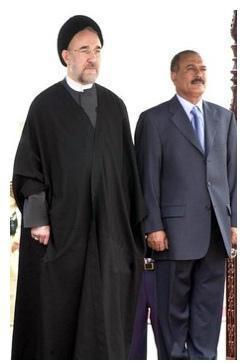How many people are in the picture?
Give a very brief answer. 2. How many zebras are there?
Give a very brief answer. 0. 